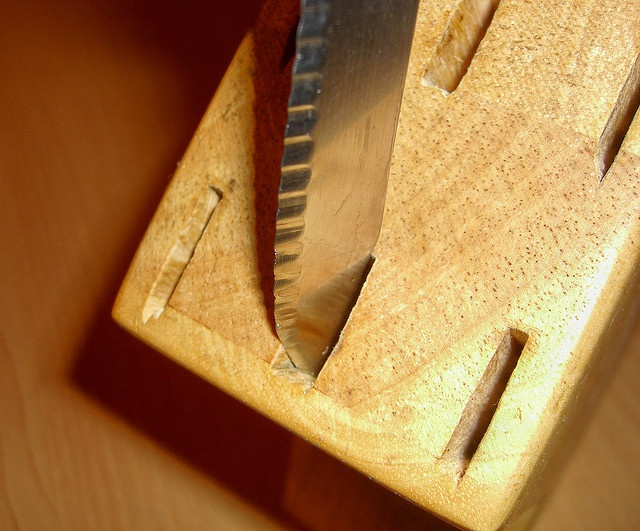Describe the objects in this image and their specific colors. I can see a knife in maroon, tan, and olive tones in this image. 